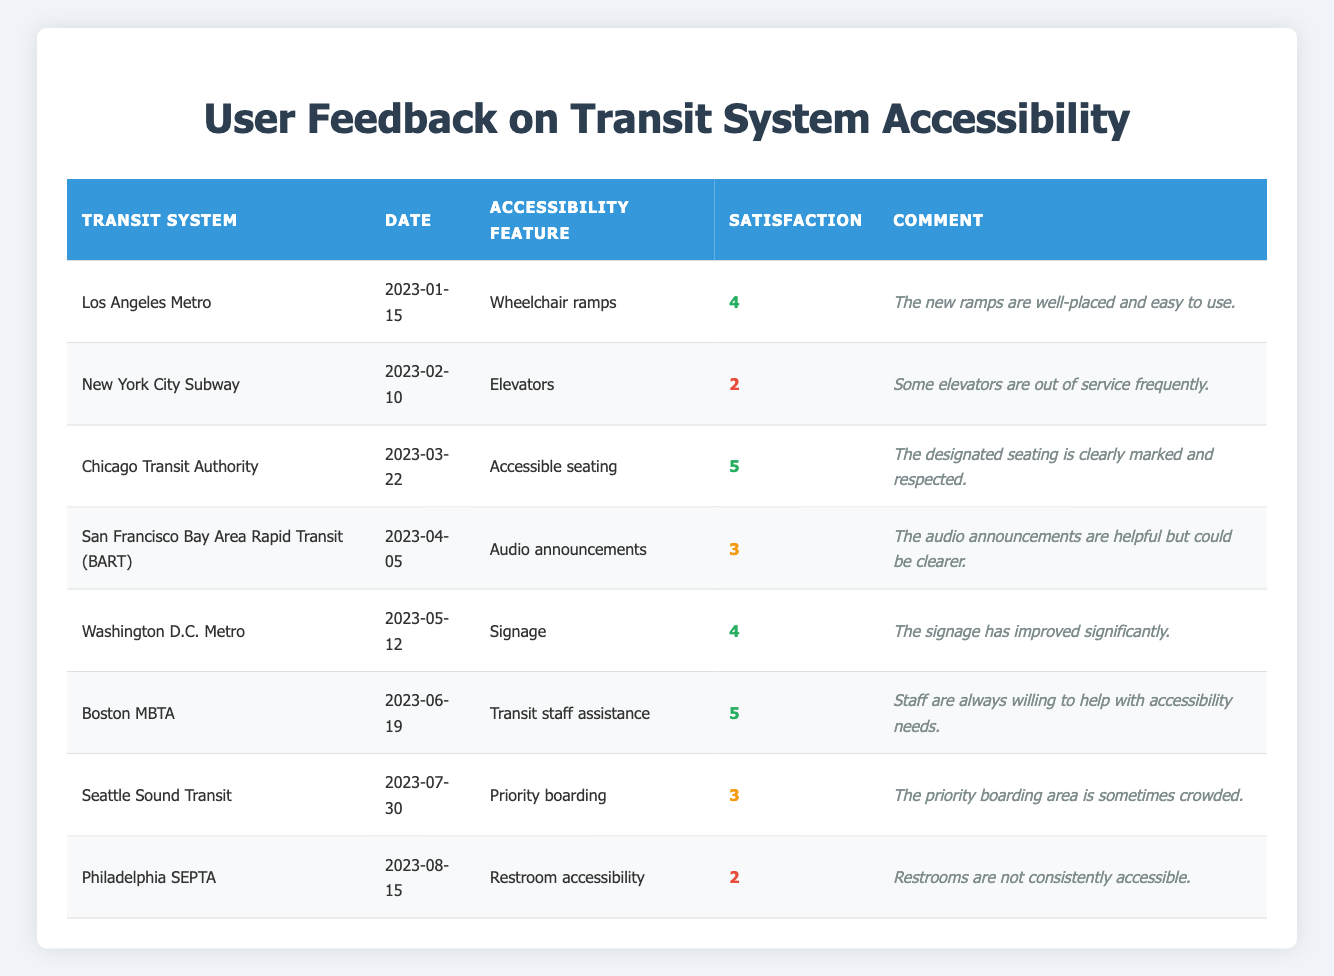What is the satisfaction rating for the Boston MBTA? Looking at the table, the satisfaction rating for the Boston MBTA is in the fourth row and the value is 5.
Answer: 5 Which transit system received the lowest satisfaction rating? The lowest satisfaction rating is represented by Philadelphia SEPTA with a rating of 2 found in the last row of the table.
Answer: Philadelphia SEPTA How many transit systems received a satisfaction rating of 4 or higher? By counting the ratings of 4 and 5: Los Angeles Metro (4), Chicago Transit Authority (5), Washington D.C. Metro (4), and Boston MBTA (5), there are four systems with 4 or higher.
Answer: 4 What is the average satisfaction rating across all the transit systems? Adding all the satisfaction ratings: 4 + 2 + 5 + 3 + 4 + 5 + 3 + 2 = 28, and then dividing by the total number of entries (8), we get 28/8 = 3.5.
Answer: 3.5 Did any user comment positively about the priority boarding feature? No user commented positively, as the highest rating is 3, and the comment states it's sometimes crowded which implies dissatisfaction.
Answer: No Which transit system had comments specifically about restroom accessibility? The table shows that Philadelphia SEPTA had feedback related to restroom accessibility, with a rating of 2 and a comment about inconsistency.
Answer: Philadelphia SEPTA How many transit systems received a satisfaction rating of 3? There are three transit systems with a satisfaction rating of 3: San Francisco BART, Seattle Sound Transit, and New York City Subway.
Answer: 3 What was the date of feedback for the highest-rated accessibility feature? The highest rating of 5 was for accessible seating on March 22, 2023, provided by the Chicago Transit Authority.
Answer: March 22, 2023 Did users find the audio announcements helpful or unclear? Users found the audio announcements helpful but noted that they could be clearer, indicated by a satisfaction rating of 3 and the comment provided.
Answer: Helpful but unclear 